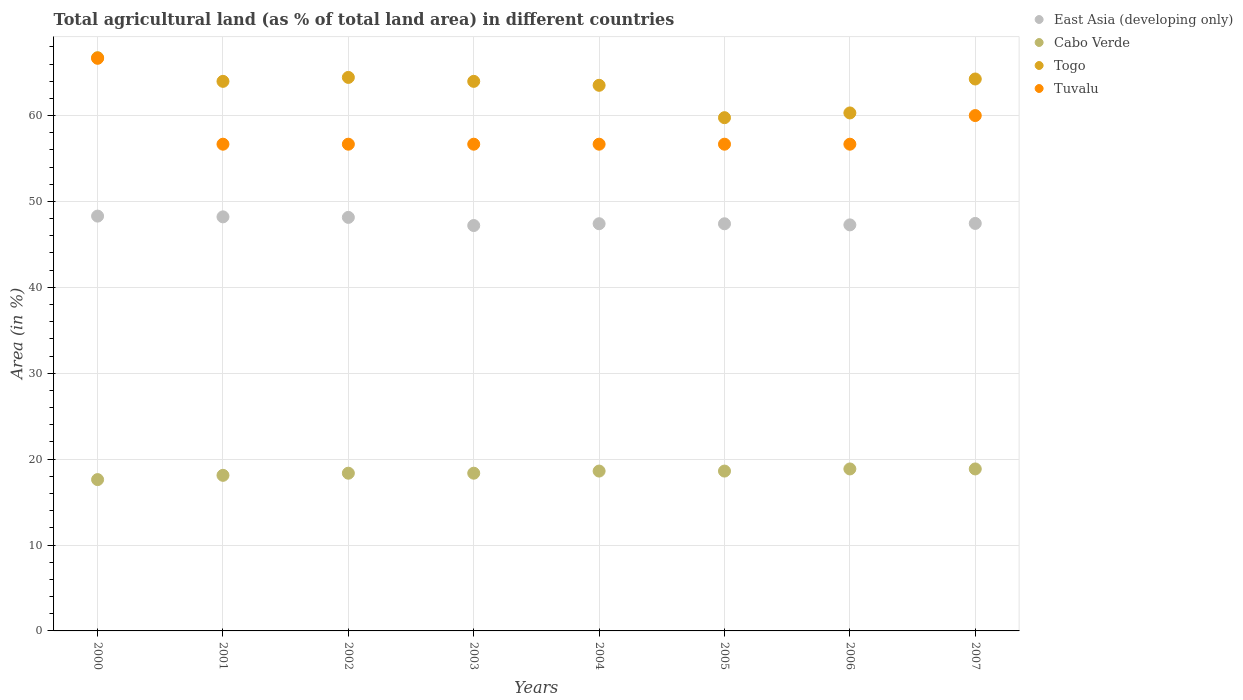Is the number of dotlines equal to the number of legend labels?
Provide a succinct answer. Yes. What is the percentage of agricultural land in Tuvalu in 2003?
Make the answer very short. 56.67. Across all years, what is the maximum percentage of agricultural land in Togo?
Make the answer very short. 66.74. Across all years, what is the minimum percentage of agricultural land in Cabo Verde?
Make the answer very short. 17.62. In which year was the percentage of agricultural land in Cabo Verde maximum?
Your answer should be very brief. 2006. In which year was the percentage of agricultural land in Togo minimum?
Give a very brief answer. 2005. What is the total percentage of agricultural land in East Asia (developing only) in the graph?
Offer a very short reply. 381.37. What is the difference between the percentage of agricultural land in East Asia (developing only) in 2006 and that in 2007?
Keep it short and to the point. -0.17. What is the difference between the percentage of agricultural land in East Asia (developing only) in 2004 and the percentage of agricultural land in Cabo Verde in 2002?
Make the answer very short. 29.05. What is the average percentage of agricultural land in Tuvalu per year?
Ensure brevity in your answer.  58.33. In the year 2000, what is the difference between the percentage of agricultural land in Togo and percentage of agricultural land in East Asia (developing only)?
Give a very brief answer. 18.45. In how many years, is the percentage of agricultural land in Togo greater than 52 %?
Provide a short and direct response. 8. What is the ratio of the percentage of agricultural land in Cabo Verde in 2002 to that in 2007?
Provide a succinct answer. 0.97. Is the percentage of agricultural land in Tuvalu in 2002 less than that in 2005?
Give a very brief answer. No. What is the difference between the highest and the second highest percentage of agricultural land in East Asia (developing only)?
Offer a terse response. 0.09. What is the difference between the highest and the lowest percentage of agricultural land in Cabo Verde?
Ensure brevity in your answer.  1.24. In how many years, is the percentage of agricultural land in Tuvalu greater than the average percentage of agricultural land in Tuvalu taken over all years?
Keep it short and to the point. 2. Is the sum of the percentage of agricultural land in Cabo Verde in 2006 and 2007 greater than the maximum percentage of agricultural land in East Asia (developing only) across all years?
Your answer should be compact. No. Does the percentage of agricultural land in Cabo Verde monotonically increase over the years?
Your answer should be very brief. No. How many dotlines are there?
Give a very brief answer. 4. How many years are there in the graph?
Offer a very short reply. 8. What is the difference between two consecutive major ticks on the Y-axis?
Your response must be concise. 10. Does the graph contain grids?
Make the answer very short. Yes. Where does the legend appear in the graph?
Make the answer very short. Top right. How are the legend labels stacked?
Provide a short and direct response. Vertical. What is the title of the graph?
Offer a terse response. Total agricultural land (as % of total land area) in different countries. Does "Ghana" appear as one of the legend labels in the graph?
Your answer should be compact. No. What is the label or title of the Y-axis?
Provide a short and direct response. Area (in %). What is the Area (in %) in East Asia (developing only) in 2000?
Offer a very short reply. 48.3. What is the Area (in %) in Cabo Verde in 2000?
Make the answer very short. 17.62. What is the Area (in %) of Togo in 2000?
Make the answer very short. 66.74. What is the Area (in %) in Tuvalu in 2000?
Offer a very short reply. 66.67. What is the Area (in %) in East Asia (developing only) in 2001?
Keep it short and to the point. 48.21. What is the Area (in %) in Cabo Verde in 2001?
Offer a very short reply. 18.11. What is the Area (in %) in Togo in 2001?
Keep it short and to the point. 63.98. What is the Area (in %) in Tuvalu in 2001?
Offer a very short reply. 56.67. What is the Area (in %) of East Asia (developing only) in 2002?
Offer a terse response. 48.15. What is the Area (in %) in Cabo Verde in 2002?
Ensure brevity in your answer.  18.36. What is the Area (in %) in Togo in 2002?
Give a very brief answer. 64.44. What is the Area (in %) in Tuvalu in 2002?
Offer a terse response. 56.67. What is the Area (in %) in East Asia (developing only) in 2003?
Your answer should be compact. 47.2. What is the Area (in %) of Cabo Verde in 2003?
Keep it short and to the point. 18.36. What is the Area (in %) in Togo in 2003?
Your answer should be compact. 63.98. What is the Area (in %) in Tuvalu in 2003?
Give a very brief answer. 56.67. What is the Area (in %) in East Asia (developing only) in 2004?
Keep it short and to the point. 47.41. What is the Area (in %) of Cabo Verde in 2004?
Provide a short and direct response. 18.61. What is the Area (in %) in Togo in 2004?
Provide a short and direct response. 63.52. What is the Area (in %) in Tuvalu in 2004?
Keep it short and to the point. 56.67. What is the Area (in %) in East Asia (developing only) in 2005?
Give a very brief answer. 47.4. What is the Area (in %) of Cabo Verde in 2005?
Offer a very short reply. 18.61. What is the Area (in %) of Togo in 2005?
Offer a terse response. 59.75. What is the Area (in %) in Tuvalu in 2005?
Your response must be concise. 56.67. What is the Area (in %) in East Asia (developing only) in 2006?
Make the answer very short. 47.27. What is the Area (in %) in Cabo Verde in 2006?
Provide a succinct answer. 18.86. What is the Area (in %) of Togo in 2006?
Make the answer very short. 60.31. What is the Area (in %) in Tuvalu in 2006?
Make the answer very short. 56.67. What is the Area (in %) in East Asia (developing only) in 2007?
Ensure brevity in your answer.  47.44. What is the Area (in %) in Cabo Verde in 2007?
Offer a very short reply. 18.86. What is the Area (in %) in Togo in 2007?
Provide a succinct answer. 64.26. Across all years, what is the maximum Area (in %) of East Asia (developing only)?
Your response must be concise. 48.3. Across all years, what is the maximum Area (in %) in Cabo Verde?
Make the answer very short. 18.86. Across all years, what is the maximum Area (in %) in Togo?
Provide a short and direct response. 66.74. Across all years, what is the maximum Area (in %) of Tuvalu?
Provide a succinct answer. 66.67. Across all years, what is the minimum Area (in %) in East Asia (developing only)?
Make the answer very short. 47.2. Across all years, what is the minimum Area (in %) in Cabo Verde?
Give a very brief answer. 17.62. Across all years, what is the minimum Area (in %) in Togo?
Your response must be concise. 59.75. Across all years, what is the minimum Area (in %) in Tuvalu?
Offer a very short reply. 56.67. What is the total Area (in %) of East Asia (developing only) in the graph?
Ensure brevity in your answer.  381.37. What is the total Area (in %) in Cabo Verde in the graph?
Your answer should be compact. 147.39. What is the total Area (in %) in Togo in the graph?
Ensure brevity in your answer.  506.99. What is the total Area (in %) of Tuvalu in the graph?
Keep it short and to the point. 466.67. What is the difference between the Area (in %) of East Asia (developing only) in 2000 and that in 2001?
Give a very brief answer. 0.09. What is the difference between the Area (in %) in Cabo Verde in 2000 and that in 2001?
Your response must be concise. -0.5. What is the difference between the Area (in %) of Togo in 2000 and that in 2001?
Keep it short and to the point. 2.76. What is the difference between the Area (in %) of East Asia (developing only) in 2000 and that in 2002?
Your answer should be very brief. 0.15. What is the difference between the Area (in %) of Cabo Verde in 2000 and that in 2002?
Your answer should be compact. -0.74. What is the difference between the Area (in %) of Togo in 2000 and that in 2002?
Provide a short and direct response. 2.3. What is the difference between the Area (in %) of East Asia (developing only) in 2000 and that in 2003?
Your answer should be very brief. 1.1. What is the difference between the Area (in %) of Cabo Verde in 2000 and that in 2003?
Keep it short and to the point. -0.74. What is the difference between the Area (in %) of Togo in 2000 and that in 2003?
Offer a very short reply. 2.76. What is the difference between the Area (in %) in East Asia (developing only) in 2000 and that in 2004?
Provide a succinct answer. 0.89. What is the difference between the Area (in %) of Cabo Verde in 2000 and that in 2004?
Provide a succinct answer. -0.99. What is the difference between the Area (in %) of Togo in 2000 and that in 2004?
Keep it short and to the point. 3.22. What is the difference between the Area (in %) in Tuvalu in 2000 and that in 2004?
Give a very brief answer. 10. What is the difference between the Area (in %) of East Asia (developing only) in 2000 and that in 2005?
Provide a succinct answer. 0.89. What is the difference between the Area (in %) in Cabo Verde in 2000 and that in 2005?
Your answer should be very brief. -0.99. What is the difference between the Area (in %) of Togo in 2000 and that in 2005?
Your answer should be very brief. 6.99. What is the difference between the Area (in %) in East Asia (developing only) in 2000 and that in 2006?
Provide a short and direct response. 1.02. What is the difference between the Area (in %) in Cabo Verde in 2000 and that in 2006?
Provide a succinct answer. -1.24. What is the difference between the Area (in %) of Togo in 2000 and that in 2006?
Ensure brevity in your answer.  6.43. What is the difference between the Area (in %) in Tuvalu in 2000 and that in 2006?
Give a very brief answer. 10. What is the difference between the Area (in %) of East Asia (developing only) in 2000 and that in 2007?
Give a very brief answer. 0.85. What is the difference between the Area (in %) of Cabo Verde in 2000 and that in 2007?
Your answer should be compact. -1.24. What is the difference between the Area (in %) in Togo in 2000 and that in 2007?
Your answer should be very brief. 2.48. What is the difference between the Area (in %) of Tuvalu in 2000 and that in 2007?
Your answer should be very brief. 6.67. What is the difference between the Area (in %) in East Asia (developing only) in 2001 and that in 2002?
Provide a succinct answer. 0.06. What is the difference between the Area (in %) of Cabo Verde in 2001 and that in 2002?
Your answer should be compact. -0.25. What is the difference between the Area (in %) of Togo in 2001 and that in 2002?
Make the answer very short. -0.46. What is the difference between the Area (in %) of Cabo Verde in 2001 and that in 2003?
Offer a very short reply. -0.25. What is the difference between the Area (in %) in East Asia (developing only) in 2001 and that in 2004?
Your answer should be compact. 0.8. What is the difference between the Area (in %) of Cabo Verde in 2001 and that in 2004?
Provide a succinct answer. -0.5. What is the difference between the Area (in %) in Togo in 2001 and that in 2004?
Provide a short and direct response. 0.46. What is the difference between the Area (in %) in East Asia (developing only) in 2001 and that in 2005?
Provide a short and direct response. 0.8. What is the difference between the Area (in %) in Cabo Verde in 2001 and that in 2005?
Ensure brevity in your answer.  -0.5. What is the difference between the Area (in %) of Togo in 2001 and that in 2005?
Keep it short and to the point. 4.23. What is the difference between the Area (in %) of Tuvalu in 2001 and that in 2005?
Give a very brief answer. 0. What is the difference between the Area (in %) of East Asia (developing only) in 2001 and that in 2006?
Provide a succinct answer. 0.93. What is the difference between the Area (in %) of Cabo Verde in 2001 and that in 2006?
Keep it short and to the point. -0.74. What is the difference between the Area (in %) of Togo in 2001 and that in 2006?
Your answer should be very brief. 3.68. What is the difference between the Area (in %) in Tuvalu in 2001 and that in 2006?
Your response must be concise. 0. What is the difference between the Area (in %) of East Asia (developing only) in 2001 and that in 2007?
Your response must be concise. 0.76. What is the difference between the Area (in %) of Cabo Verde in 2001 and that in 2007?
Ensure brevity in your answer.  -0.74. What is the difference between the Area (in %) of Togo in 2001 and that in 2007?
Provide a short and direct response. -0.28. What is the difference between the Area (in %) in East Asia (developing only) in 2002 and that in 2003?
Ensure brevity in your answer.  0.95. What is the difference between the Area (in %) of Cabo Verde in 2002 and that in 2003?
Your response must be concise. 0. What is the difference between the Area (in %) in Togo in 2002 and that in 2003?
Keep it short and to the point. 0.46. What is the difference between the Area (in %) of East Asia (developing only) in 2002 and that in 2004?
Provide a succinct answer. 0.74. What is the difference between the Area (in %) of Cabo Verde in 2002 and that in 2004?
Offer a very short reply. -0.25. What is the difference between the Area (in %) of Togo in 2002 and that in 2004?
Provide a short and direct response. 0.92. What is the difference between the Area (in %) of East Asia (developing only) in 2002 and that in 2005?
Offer a very short reply. 0.74. What is the difference between the Area (in %) in Cabo Verde in 2002 and that in 2005?
Offer a terse response. -0.25. What is the difference between the Area (in %) of Togo in 2002 and that in 2005?
Make the answer very short. 4.69. What is the difference between the Area (in %) of Tuvalu in 2002 and that in 2005?
Provide a succinct answer. 0. What is the difference between the Area (in %) of East Asia (developing only) in 2002 and that in 2006?
Your response must be concise. 0.87. What is the difference between the Area (in %) in Cabo Verde in 2002 and that in 2006?
Your response must be concise. -0.5. What is the difference between the Area (in %) of Togo in 2002 and that in 2006?
Keep it short and to the point. 4.14. What is the difference between the Area (in %) in East Asia (developing only) in 2002 and that in 2007?
Keep it short and to the point. 0.7. What is the difference between the Area (in %) of Cabo Verde in 2002 and that in 2007?
Your response must be concise. -0.5. What is the difference between the Area (in %) of Togo in 2002 and that in 2007?
Your answer should be very brief. 0.18. What is the difference between the Area (in %) of Tuvalu in 2002 and that in 2007?
Give a very brief answer. -3.33. What is the difference between the Area (in %) in East Asia (developing only) in 2003 and that in 2004?
Your response must be concise. -0.21. What is the difference between the Area (in %) in Cabo Verde in 2003 and that in 2004?
Your answer should be very brief. -0.25. What is the difference between the Area (in %) in Togo in 2003 and that in 2004?
Your response must be concise. 0.46. What is the difference between the Area (in %) in East Asia (developing only) in 2003 and that in 2005?
Your response must be concise. -0.21. What is the difference between the Area (in %) in Cabo Verde in 2003 and that in 2005?
Your answer should be very brief. -0.25. What is the difference between the Area (in %) of Togo in 2003 and that in 2005?
Your answer should be very brief. 4.23. What is the difference between the Area (in %) of Tuvalu in 2003 and that in 2005?
Give a very brief answer. 0. What is the difference between the Area (in %) of East Asia (developing only) in 2003 and that in 2006?
Your response must be concise. -0.08. What is the difference between the Area (in %) of Cabo Verde in 2003 and that in 2006?
Your response must be concise. -0.5. What is the difference between the Area (in %) of Togo in 2003 and that in 2006?
Your response must be concise. 3.68. What is the difference between the Area (in %) in Tuvalu in 2003 and that in 2006?
Your response must be concise. 0. What is the difference between the Area (in %) of East Asia (developing only) in 2003 and that in 2007?
Offer a terse response. -0.25. What is the difference between the Area (in %) of Cabo Verde in 2003 and that in 2007?
Your answer should be compact. -0.5. What is the difference between the Area (in %) in Togo in 2003 and that in 2007?
Offer a very short reply. -0.28. What is the difference between the Area (in %) of East Asia (developing only) in 2004 and that in 2005?
Your answer should be very brief. 0.01. What is the difference between the Area (in %) of Cabo Verde in 2004 and that in 2005?
Offer a terse response. 0. What is the difference between the Area (in %) of Togo in 2004 and that in 2005?
Offer a terse response. 3.77. What is the difference between the Area (in %) of East Asia (developing only) in 2004 and that in 2006?
Your response must be concise. 0.14. What is the difference between the Area (in %) in Cabo Verde in 2004 and that in 2006?
Keep it short and to the point. -0.25. What is the difference between the Area (in %) of Togo in 2004 and that in 2006?
Keep it short and to the point. 3.22. What is the difference between the Area (in %) of Tuvalu in 2004 and that in 2006?
Offer a terse response. 0. What is the difference between the Area (in %) of East Asia (developing only) in 2004 and that in 2007?
Your answer should be very brief. -0.03. What is the difference between the Area (in %) of Cabo Verde in 2004 and that in 2007?
Provide a short and direct response. -0.25. What is the difference between the Area (in %) in Togo in 2004 and that in 2007?
Give a very brief answer. -0.74. What is the difference between the Area (in %) of East Asia (developing only) in 2005 and that in 2006?
Make the answer very short. 0.13. What is the difference between the Area (in %) in Cabo Verde in 2005 and that in 2006?
Keep it short and to the point. -0.25. What is the difference between the Area (in %) in Togo in 2005 and that in 2006?
Provide a short and direct response. -0.55. What is the difference between the Area (in %) in Tuvalu in 2005 and that in 2006?
Provide a succinct answer. 0. What is the difference between the Area (in %) in East Asia (developing only) in 2005 and that in 2007?
Make the answer very short. -0.04. What is the difference between the Area (in %) of Cabo Verde in 2005 and that in 2007?
Your answer should be very brief. -0.25. What is the difference between the Area (in %) in Togo in 2005 and that in 2007?
Your response must be concise. -4.5. What is the difference between the Area (in %) of East Asia (developing only) in 2006 and that in 2007?
Your answer should be compact. -0.17. What is the difference between the Area (in %) in Togo in 2006 and that in 2007?
Offer a terse response. -3.95. What is the difference between the Area (in %) of East Asia (developing only) in 2000 and the Area (in %) of Cabo Verde in 2001?
Your answer should be compact. 30.18. What is the difference between the Area (in %) of East Asia (developing only) in 2000 and the Area (in %) of Togo in 2001?
Provide a succinct answer. -15.69. What is the difference between the Area (in %) of East Asia (developing only) in 2000 and the Area (in %) of Tuvalu in 2001?
Your response must be concise. -8.37. What is the difference between the Area (in %) in Cabo Verde in 2000 and the Area (in %) in Togo in 2001?
Offer a very short reply. -46.36. What is the difference between the Area (in %) of Cabo Verde in 2000 and the Area (in %) of Tuvalu in 2001?
Your answer should be very brief. -39.05. What is the difference between the Area (in %) in Togo in 2000 and the Area (in %) in Tuvalu in 2001?
Offer a terse response. 10.07. What is the difference between the Area (in %) in East Asia (developing only) in 2000 and the Area (in %) in Cabo Verde in 2002?
Make the answer very short. 29.93. What is the difference between the Area (in %) in East Asia (developing only) in 2000 and the Area (in %) in Togo in 2002?
Keep it short and to the point. -16.15. What is the difference between the Area (in %) in East Asia (developing only) in 2000 and the Area (in %) in Tuvalu in 2002?
Provide a succinct answer. -8.37. What is the difference between the Area (in %) in Cabo Verde in 2000 and the Area (in %) in Togo in 2002?
Make the answer very short. -46.82. What is the difference between the Area (in %) of Cabo Verde in 2000 and the Area (in %) of Tuvalu in 2002?
Your answer should be very brief. -39.05. What is the difference between the Area (in %) in Togo in 2000 and the Area (in %) in Tuvalu in 2002?
Offer a very short reply. 10.07. What is the difference between the Area (in %) in East Asia (developing only) in 2000 and the Area (in %) in Cabo Verde in 2003?
Provide a succinct answer. 29.93. What is the difference between the Area (in %) of East Asia (developing only) in 2000 and the Area (in %) of Togo in 2003?
Offer a very short reply. -15.69. What is the difference between the Area (in %) of East Asia (developing only) in 2000 and the Area (in %) of Tuvalu in 2003?
Offer a terse response. -8.37. What is the difference between the Area (in %) in Cabo Verde in 2000 and the Area (in %) in Togo in 2003?
Your response must be concise. -46.36. What is the difference between the Area (in %) of Cabo Verde in 2000 and the Area (in %) of Tuvalu in 2003?
Offer a very short reply. -39.05. What is the difference between the Area (in %) of Togo in 2000 and the Area (in %) of Tuvalu in 2003?
Make the answer very short. 10.07. What is the difference between the Area (in %) in East Asia (developing only) in 2000 and the Area (in %) in Cabo Verde in 2004?
Offer a terse response. 29.68. What is the difference between the Area (in %) in East Asia (developing only) in 2000 and the Area (in %) in Togo in 2004?
Your answer should be very brief. -15.23. What is the difference between the Area (in %) in East Asia (developing only) in 2000 and the Area (in %) in Tuvalu in 2004?
Provide a short and direct response. -8.37. What is the difference between the Area (in %) in Cabo Verde in 2000 and the Area (in %) in Togo in 2004?
Provide a short and direct response. -45.9. What is the difference between the Area (in %) of Cabo Verde in 2000 and the Area (in %) of Tuvalu in 2004?
Keep it short and to the point. -39.05. What is the difference between the Area (in %) in Togo in 2000 and the Area (in %) in Tuvalu in 2004?
Keep it short and to the point. 10.07. What is the difference between the Area (in %) in East Asia (developing only) in 2000 and the Area (in %) in Cabo Verde in 2005?
Offer a very short reply. 29.68. What is the difference between the Area (in %) of East Asia (developing only) in 2000 and the Area (in %) of Togo in 2005?
Ensure brevity in your answer.  -11.46. What is the difference between the Area (in %) in East Asia (developing only) in 2000 and the Area (in %) in Tuvalu in 2005?
Provide a short and direct response. -8.37. What is the difference between the Area (in %) of Cabo Verde in 2000 and the Area (in %) of Togo in 2005?
Make the answer very short. -42.14. What is the difference between the Area (in %) of Cabo Verde in 2000 and the Area (in %) of Tuvalu in 2005?
Your answer should be compact. -39.05. What is the difference between the Area (in %) of Togo in 2000 and the Area (in %) of Tuvalu in 2005?
Offer a terse response. 10.07. What is the difference between the Area (in %) of East Asia (developing only) in 2000 and the Area (in %) of Cabo Verde in 2006?
Offer a very short reply. 29.44. What is the difference between the Area (in %) of East Asia (developing only) in 2000 and the Area (in %) of Togo in 2006?
Offer a terse response. -12.01. What is the difference between the Area (in %) in East Asia (developing only) in 2000 and the Area (in %) in Tuvalu in 2006?
Make the answer very short. -8.37. What is the difference between the Area (in %) of Cabo Verde in 2000 and the Area (in %) of Togo in 2006?
Provide a short and direct response. -42.69. What is the difference between the Area (in %) of Cabo Verde in 2000 and the Area (in %) of Tuvalu in 2006?
Your answer should be very brief. -39.05. What is the difference between the Area (in %) of Togo in 2000 and the Area (in %) of Tuvalu in 2006?
Ensure brevity in your answer.  10.07. What is the difference between the Area (in %) of East Asia (developing only) in 2000 and the Area (in %) of Cabo Verde in 2007?
Offer a very short reply. 29.44. What is the difference between the Area (in %) in East Asia (developing only) in 2000 and the Area (in %) in Togo in 2007?
Keep it short and to the point. -15.96. What is the difference between the Area (in %) in East Asia (developing only) in 2000 and the Area (in %) in Tuvalu in 2007?
Your response must be concise. -11.7. What is the difference between the Area (in %) of Cabo Verde in 2000 and the Area (in %) of Togo in 2007?
Ensure brevity in your answer.  -46.64. What is the difference between the Area (in %) in Cabo Verde in 2000 and the Area (in %) in Tuvalu in 2007?
Your response must be concise. -42.38. What is the difference between the Area (in %) in Togo in 2000 and the Area (in %) in Tuvalu in 2007?
Provide a succinct answer. 6.74. What is the difference between the Area (in %) of East Asia (developing only) in 2001 and the Area (in %) of Cabo Verde in 2002?
Your answer should be compact. 29.84. What is the difference between the Area (in %) in East Asia (developing only) in 2001 and the Area (in %) in Togo in 2002?
Your answer should be very brief. -16.24. What is the difference between the Area (in %) in East Asia (developing only) in 2001 and the Area (in %) in Tuvalu in 2002?
Make the answer very short. -8.46. What is the difference between the Area (in %) in Cabo Verde in 2001 and the Area (in %) in Togo in 2002?
Keep it short and to the point. -46.33. What is the difference between the Area (in %) of Cabo Verde in 2001 and the Area (in %) of Tuvalu in 2002?
Offer a very short reply. -38.55. What is the difference between the Area (in %) of Togo in 2001 and the Area (in %) of Tuvalu in 2002?
Provide a succinct answer. 7.32. What is the difference between the Area (in %) of East Asia (developing only) in 2001 and the Area (in %) of Cabo Verde in 2003?
Keep it short and to the point. 29.84. What is the difference between the Area (in %) of East Asia (developing only) in 2001 and the Area (in %) of Togo in 2003?
Your answer should be compact. -15.78. What is the difference between the Area (in %) of East Asia (developing only) in 2001 and the Area (in %) of Tuvalu in 2003?
Make the answer very short. -8.46. What is the difference between the Area (in %) of Cabo Verde in 2001 and the Area (in %) of Togo in 2003?
Your response must be concise. -45.87. What is the difference between the Area (in %) of Cabo Verde in 2001 and the Area (in %) of Tuvalu in 2003?
Provide a succinct answer. -38.55. What is the difference between the Area (in %) in Togo in 2001 and the Area (in %) in Tuvalu in 2003?
Provide a succinct answer. 7.32. What is the difference between the Area (in %) of East Asia (developing only) in 2001 and the Area (in %) of Cabo Verde in 2004?
Your response must be concise. 29.6. What is the difference between the Area (in %) in East Asia (developing only) in 2001 and the Area (in %) in Togo in 2004?
Offer a terse response. -15.32. What is the difference between the Area (in %) of East Asia (developing only) in 2001 and the Area (in %) of Tuvalu in 2004?
Your answer should be compact. -8.46. What is the difference between the Area (in %) in Cabo Verde in 2001 and the Area (in %) in Togo in 2004?
Keep it short and to the point. -45.41. What is the difference between the Area (in %) in Cabo Verde in 2001 and the Area (in %) in Tuvalu in 2004?
Your answer should be compact. -38.55. What is the difference between the Area (in %) of Togo in 2001 and the Area (in %) of Tuvalu in 2004?
Your response must be concise. 7.32. What is the difference between the Area (in %) of East Asia (developing only) in 2001 and the Area (in %) of Cabo Verde in 2005?
Your answer should be compact. 29.6. What is the difference between the Area (in %) of East Asia (developing only) in 2001 and the Area (in %) of Togo in 2005?
Offer a very short reply. -11.55. What is the difference between the Area (in %) of East Asia (developing only) in 2001 and the Area (in %) of Tuvalu in 2005?
Make the answer very short. -8.46. What is the difference between the Area (in %) of Cabo Verde in 2001 and the Area (in %) of Togo in 2005?
Provide a short and direct response. -41.64. What is the difference between the Area (in %) in Cabo Verde in 2001 and the Area (in %) in Tuvalu in 2005?
Keep it short and to the point. -38.55. What is the difference between the Area (in %) in Togo in 2001 and the Area (in %) in Tuvalu in 2005?
Give a very brief answer. 7.32. What is the difference between the Area (in %) of East Asia (developing only) in 2001 and the Area (in %) of Cabo Verde in 2006?
Give a very brief answer. 29.35. What is the difference between the Area (in %) in East Asia (developing only) in 2001 and the Area (in %) in Togo in 2006?
Your answer should be very brief. -12.1. What is the difference between the Area (in %) of East Asia (developing only) in 2001 and the Area (in %) of Tuvalu in 2006?
Offer a terse response. -8.46. What is the difference between the Area (in %) in Cabo Verde in 2001 and the Area (in %) in Togo in 2006?
Make the answer very short. -42.19. What is the difference between the Area (in %) of Cabo Verde in 2001 and the Area (in %) of Tuvalu in 2006?
Your answer should be very brief. -38.55. What is the difference between the Area (in %) of Togo in 2001 and the Area (in %) of Tuvalu in 2006?
Provide a short and direct response. 7.32. What is the difference between the Area (in %) in East Asia (developing only) in 2001 and the Area (in %) in Cabo Verde in 2007?
Ensure brevity in your answer.  29.35. What is the difference between the Area (in %) in East Asia (developing only) in 2001 and the Area (in %) in Togo in 2007?
Keep it short and to the point. -16.05. What is the difference between the Area (in %) in East Asia (developing only) in 2001 and the Area (in %) in Tuvalu in 2007?
Offer a terse response. -11.79. What is the difference between the Area (in %) of Cabo Verde in 2001 and the Area (in %) of Togo in 2007?
Ensure brevity in your answer.  -46.14. What is the difference between the Area (in %) in Cabo Verde in 2001 and the Area (in %) in Tuvalu in 2007?
Keep it short and to the point. -41.89. What is the difference between the Area (in %) of Togo in 2001 and the Area (in %) of Tuvalu in 2007?
Make the answer very short. 3.98. What is the difference between the Area (in %) in East Asia (developing only) in 2002 and the Area (in %) in Cabo Verde in 2003?
Make the answer very short. 29.78. What is the difference between the Area (in %) in East Asia (developing only) in 2002 and the Area (in %) in Togo in 2003?
Provide a short and direct response. -15.84. What is the difference between the Area (in %) in East Asia (developing only) in 2002 and the Area (in %) in Tuvalu in 2003?
Your response must be concise. -8.52. What is the difference between the Area (in %) in Cabo Verde in 2002 and the Area (in %) in Togo in 2003?
Your answer should be very brief. -45.62. What is the difference between the Area (in %) in Cabo Verde in 2002 and the Area (in %) in Tuvalu in 2003?
Offer a terse response. -38.3. What is the difference between the Area (in %) of Togo in 2002 and the Area (in %) of Tuvalu in 2003?
Keep it short and to the point. 7.78. What is the difference between the Area (in %) of East Asia (developing only) in 2002 and the Area (in %) of Cabo Verde in 2004?
Give a very brief answer. 29.54. What is the difference between the Area (in %) in East Asia (developing only) in 2002 and the Area (in %) in Togo in 2004?
Give a very brief answer. -15.38. What is the difference between the Area (in %) of East Asia (developing only) in 2002 and the Area (in %) of Tuvalu in 2004?
Your answer should be very brief. -8.52. What is the difference between the Area (in %) of Cabo Verde in 2002 and the Area (in %) of Togo in 2004?
Make the answer very short. -45.16. What is the difference between the Area (in %) in Cabo Verde in 2002 and the Area (in %) in Tuvalu in 2004?
Make the answer very short. -38.3. What is the difference between the Area (in %) in Togo in 2002 and the Area (in %) in Tuvalu in 2004?
Your answer should be compact. 7.78. What is the difference between the Area (in %) of East Asia (developing only) in 2002 and the Area (in %) of Cabo Verde in 2005?
Offer a terse response. 29.54. What is the difference between the Area (in %) of East Asia (developing only) in 2002 and the Area (in %) of Togo in 2005?
Your answer should be compact. -11.61. What is the difference between the Area (in %) in East Asia (developing only) in 2002 and the Area (in %) in Tuvalu in 2005?
Offer a terse response. -8.52. What is the difference between the Area (in %) of Cabo Verde in 2002 and the Area (in %) of Togo in 2005?
Offer a terse response. -41.39. What is the difference between the Area (in %) of Cabo Verde in 2002 and the Area (in %) of Tuvalu in 2005?
Provide a succinct answer. -38.3. What is the difference between the Area (in %) in Togo in 2002 and the Area (in %) in Tuvalu in 2005?
Ensure brevity in your answer.  7.78. What is the difference between the Area (in %) in East Asia (developing only) in 2002 and the Area (in %) in Cabo Verde in 2006?
Your response must be concise. 29.29. What is the difference between the Area (in %) in East Asia (developing only) in 2002 and the Area (in %) in Togo in 2006?
Your response must be concise. -12.16. What is the difference between the Area (in %) of East Asia (developing only) in 2002 and the Area (in %) of Tuvalu in 2006?
Make the answer very short. -8.52. What is the difference between the Area (in %) of Cabo Verde in 2002 and the Area (in %) of Togo in 2006?
Your answer should be very brief. -41.94. What is the difference between the Area (in %) of Cabo Verde in 2002 and the Area (in %) of Tuvalu in 2006?
Provide a succinct answer. -38.3. What is the difference between the Area (in %) in Togo in 2002 and the Area (in %) in Tuvalu in 2006?
Provide a succinct answer. 7.78. What is the difference between the Area (in %) in East Asia (developing only) in 2002 and the Area (in %) in Cabo Verde in 2007?
Provide a short and direct response. 29.29. What is the difference between the Area (in %) of East Asia (developing only) in 2002 and the Area (in %) of Togo in 2007?
Offer a very short reply. -16.11. What is the difference between the Area (in %) of East Asia (developing only) in 2002 and the Area (in %) of Tuvalu in 2007?
Your answer should be very brief. -11.85. What is the difference between the Area (in %) of Cabo Verde in 2002 and the Area (in %) of Togo in 2007?
Offer a terse response. -45.9. What is the difference between the Area (in %) in Cabo Verde in 2002 and the Area (in %) in Tuvalu in 2007?
Keep it short and to the point. -41.64. What is the difference between the Area (in %) in Togo in 2002 and the Area (in %) in Tuvalu in 2007?
Your answer should be very brief. 4.44. What is the difference between the Area (in %) of East Asia (developing only) in 2003 and the Area (in %) of Cabo Verde in 2004?
Your response must be concise. 28.59. What is the difference between the Area (in %) in East Asia (developing only) in 2003 and the Area (in %) in Togo in 2004?
Keep it short and to the point. -16.33. What is the difference between the Area (in %) in East Asia (developing only) in 2003 and the Area (in %) in Tuvalu in 2004?
Your answer should be very brief. -9.47. What is the difference between the Area (in %) in Cabo Verde in 2003 and the Area (in %) in Togo in 2004?
Keep it short and to the point. -45.16. What is the difference between the Area (in %) of Cabo Verde in 2003 and the Area (in %) of Tuvalu in 2004?
Offer a very short reply. -38.3. What is the difference between the Area (in %) of Togo in 2003 and the Area (in %) of Tuvalu in 2004?
Offer a very short reply. 7.32. What is the difference between the Area (in %) in East Asia (developing only) in 2003 and the Area (in %) in Cabo Verde in 2005?
Ensure brevity in your answer.  28.59. What is the difference between the Area (in %) of East Asia (developing only) in 2003 and the Area (in %) of Togo in 2005?
Provide a succinct answer. -12.56. What is the difference between the Area (in %) in East Asia (developing only) in 2003 and the Area (in %) in Tuvalu in 2005?
Make the answer very short. -9.47. What is the difference between the Area (in %) of Cabo Verde in 2003 and the Area (in %) of Togo in 2005?
Provide a short and direct response. -41.39. What is the difference between the Area (in %) in Cabo Verde in 2003 and the Area (in %) in Tuvalu in 2005?
Ensure brevity in your answer.  -38.3. What is the difference between the Area (in %) in Togo in 2003 and the Area (in %) in Tuvalu in 2005?
Provide a succinct answer. 7.32. What is the difference between the Area (in %) in East Asia (developing only) in 2003 and the Area (in %) in Cabo Verde in 2006?
Offer a very short reply. 28.34. What is the difference between the Area (in %) in East Asia (developing only) in 2003 and the Area (in %) in Togo in 2006?
Give a very brief answer. -13.11. What is the difference between the Area (in %) in East Asia (developing only) in 2003 and the Area (in %) in Tuvalu in 2006?
Make the answer very short. -9.47. What is the difference between the Area (in %) in Cabo Verde in 2003 and the Area (in %) in Togo in 2006?
Offer a terse response. -41.94. What is the difference between the Area (in %) of Cabo Verde in 2003 and the Area (in %) of Tuvalu in 2006?
Keep it short and to the point. -38.3. What is the difference between the Area (in %) in Togo in 2003 and the Area (in %) in Tuvalu in 2006?
Your response must be concise. 7.32. What is the difference between the Area (in %) in East Asia (developing only) in 2003 and the Area (in %) in Cabo Verde in 2007?
Offer a very short reply. 28.34. What is the difference between the Area (in %) in East Asia (developing only) in 2003 and the Area (in %) in Togo in 2007?
Your answer should be very brief. -17.06. What is the difference between the Area (in %) of East Asia (developing only) in 2003 and the Area (in %) of Tuvalu in 2007?
Provide a succinct answer. -12.8. What is the difference between the Area (in %) in Cabo Verde in 2003 and the Area (in %) in Togo in 2007?
Make the answer very short. -45.9. What is the difference between the Area (in %) in Cabo Verde in 2003 and the Area (in %) in Tuvalu in 2007?
Your answer should be compact. -41.64. What is the difference between the Area (in %) of Togo in 2003 and the Area (in %) of Tuvalu in 2007?
Ensure brevity in your answer.  3.98. What is the difference between the Area (in %) of East Asia (developing only) in 2004 and the Area (in %) of Cabo Verde in 2005?
Offer a terse response. 28.8. What is the difference between the Area (in %) in East Asia (developing only) in 2004 and the Area (in %) in Togo in 2005?
Keep it short and to the point. -12.35. What is the difference between the Area (in %) in East Asia (developing only) in 2004 and the Area (in %) in Tuvalu in 2005?
Your answer should be compact. -9.26. What is the difference between the Area (in %) of Cabo Verde in 2004 and the Area (in %) of Togo in 2005?
Provide a short and direct response. -41.14. What is the difference between the Area (in %) in Cabo Verde in 2004 and the Area (in %) in Tuvalu in 2005?
Your answer should be compact. -38.06. What is the difference between the Area (in %) in Togo in 2004 and the Area (in %) in Tuvalu in 2005?
Keep it short and to the point. 6.86. What is the difference between the Area (in %) in East Asia (developing only) in 2004 and the Area (in %) in Cabo Verde in 2006?
Offer a very short reply. 28.55. What is the difference between the Area (in %) in East Asia (developing only) in 2004 and the Area (in %) in Togo in 2006?
Ensure brevity in your answer.  -12.9. What is the difference between the Area (in %) in East Asia (developing only) in 2004 and the Area (in %) in Tuvalu in 2006?
Make the answer very short. -9.26. What is the difference between the Area (in %) of Cabo Verde in 2004 and the Area (in %) of Togo in 2006?
Offer a terse response. -41.69. What is the difference between the Area (in %) in Cabo Verde in 2004 and the Area (in %) in Tuvalu in 2006?
Offer a terse response. -38.06. What is the difference between the Area (in %) in Togo in 2004 and the Area (in %) in Tuvalu in 2006?
Make the answer very short. 6.86. What is the difference between the Area (in %) of East Asia (developing only) in 2004 and the Area (in %) of Cabo Verde in 2007?
Ensure brevity in your answer.  28.55. What is the difference between the Area (in %) in East Asia (developing only) in 2004 and the Area (in %) in Togo in 2007?
Offer a very short reply. -16.85. What is the difference between the Area (in %) of East Asia (developing only) in 2004 and the Area (in %) of Tuvalu in 2007?
Your answer should be very brief. -12.59. What is the difference between the Area (in %) of Cabo Verde in 2004 and the Area (in %) of Togo in 2007?
Give a very brief answer. -45.65. What is the difference between the Area (in %) in Cabo Verde in 2004 and the Area (in %) in Tuvalu in 2007?
Keep it short and to the point. -41.39. What is the difference between the Area (in %) in Togo in 2004 and the Area (in %) in Tuvalu in 2007?
Keep it short and to the point. 3.52. What is the difference between the Area (in %) in East Asia (developing only) in 2005 and the Area (in %) in Cabo Verde in 2006?
Make the answer very short. 28.54. What is the difference between the Area (in %) in East Asia (developing only) in 2005 and the Area (in %) in Togo in 2006?
Make the answer very short. -12.9. What is the difference between the Area (in %) in East Asia (developing only) in 2005 and the Area (in %) in Tuvalu in 2006?
Offer a very short reply. -9.26. What is the difference between the Area (in %) of Cabo Verde in 2005 and the Area (in %) of Togo in 2006?
Your answer should be very brief. -41.69. What is the difference between the Area (in %) of Cabo Verde in 2005 and the Area (in %) of Tuvalu in 2006?
Your answer should be very brief. -38.06. What is the difference between the Area (in %) in Togo in 2005 and the Area (in %) in Tuvalu in 2006?
Offer a very short reply. 3.09. What is the difference between the Area (in %) of East Asia (developing only) in 2005 and the Area (in %) of Cabo Verde in 2007?
Offer a very short reply. 28.54. What is the difference between the Area (in %) of East Asia (developing only) in 2005 and the Area (in %) of Togo in 2007?
Your answer should be very brief. -16.86. What is the difference between the Area (in %) of East Asia (developing only) in 2005 and the Area (in %) of Tuvalu in 2007?
Your response must be concise. -12.6. What is the difference between the Area (in %) in Cabo Verde in 2005 and the Area (in %) in Togo in 2007?
Offer a terse response. -45.65. What is the difference between the Area (in %) of Cabo Verde in 2005 and the Area (in %) of Tuvalu in 2007?
Provide a succinct answer. -41.39. What is the difference between the Area (in %) of Togo in 2005 and the Area (in %) of Tuvalu in 2007?
Keep it short and to the point. -0.25. What is the difference between the Area (in %) of East Asia (developing only) in 2006 and the Area (in %) of Cabo Verde in 2007?
Keep it short and to the point. 28.41. What is the difference between the Area (in %) of East Asia (developing only) in 2006 and the Area (in %) of Togo in 2007?
Your answer should be very brief. -16.99. What is the difference between the Area (in %) of East Asia (developing only) in 2006 and the Area (in %) of Tuvalu in 2007?
Your response must be concise. -12.73. What is the difference between the Area (in %) in Cabo Verde in 2006 and the Area (in %) in Togo in 2007?
Your response must be concise. -45.4. What is the difference between the Area (in %) of Cabo Verde in 2006 and the Area (in %) of Tuvalu in 2007?
Your answer should be very brief. -41.14. What is the difference between the Area (in %) of Togo in 2006 and the Area (in %) of Tuvalu in 2007?
Give a very brief answer. 0.31. What is the average Area (in %) of East Asia (developing only) per year?
Provide a succinct answer. 47.67. What is the average Area (in %) of Cabo Verde per year?
Make the answer very short. 18.42. What is the average Area (in %) of Togo per year?
Give a very brief answer. 63.37. What is the average Area (in %) of Tuvalu per year?
Offer a very short reply. 58.33. In the year 2000, what is the difference between the Area (in %) in East Asia (developing only) and Area (in %) in Cabo Verde?
Provide a succinct answer. 30.68. In the year 2000, what is the difference between the Area (in %) of East Asia (developing only) and Area (in %) of Togo?
Your answer should be compact. -18.45. In the year 2000, what is the difference between the Area (in %) of East Asia (developing only) and Area (in %) of Tuvalu?
Your answer should be compact. -18.37. In the year 2000, what is the difference between the Area (in %) of Cabo Verde and Area (in %) of Togo?
Your response must be concise. -49.12. In the year 2000, what is the difference between the Area (in %) of Cabo Verde and Area (in %) of Tuvalu?
Provide a succinct answer. -49.05. In the year 2000, what is the difference between the Area (in %) in Togo and Area (in %) in Tuvalu?
Your response must be concise. 0.07. In the year 2001, what is the difference between the Area (in %) of East Asia (developing only) and Area (in %) of Cabo Verde?
Offer a very short reply. 30.09. In the year 2001, what is the difference between the Area (in %) in East Asia (developing only) and Area (in %) in Togo?
Ensure brevity in your answer.  -15.78. In the year 2001, what is the difference between the Area (in %) of East Asia (developing only) and Area (in %) of Tuvalu?
Ensure brevity in your answer.  -8.46. In the year 2001, what is the difference between the Area (in %) of Cabo Verde and Area (in %) of Togo?
Keep it short and to the point. -45.87. In the year 2001, what is the difference between the Area (in %) in Cabo Verde and Area (in %) in Tuvalu?
Provide a short and direct response. -38.55. In the year 2001, what is the difference between the Area (in %) in Togo and Area (in %) in Tuvalu?
Provide a succinct answer. 7.32. In the year 2002, what is the difference between the Area (in %) in East Asia (developing only) and Area (in %) in Cabo Verde?
Ensure brevity in your answer.  29.78. In the year 2002, what is the difference between the Area (in %) in East Asia (developing only) and Area (in %) in Togo?
Ensure brevity in your answer.  -16.3. In the year 2002, what is the difference between the Area (in %) in East Asia (developing only) and Area (in %) in Tuvalu?
Make the answer very short. -8.52. In the year 2002, what is the difference between the Area (in %) in Cabo Verde and Area (in %) in Togo?
Make the answer very short. -46.08. In the year 2002, what is the difference between the Area (in %) in Cabo Verde and Area (in %) in Tuvalu?
Your response must be concise. -38.3. In the year 2002, what is the difference between the Area (in %) of Togo and Area (in %) of Tuvalu?
Provide a succinct answer. 7.78. In the year 2003, what is the difference between the Area (in %) in East Asia (developing only) and Area (in %) in Cabo Verde?
Give a very brief answer. 28.83. In the year 2003, what is the difference between the Area (in %) of East Asia (developing only) and Area (in %) of Togo?
Offer a very short reply. -16.79. In the year 2003, what is the difference between the Area (in %) in East Asia (developing only) and Area (in %) in Tuvalu?
Provide a succinct answer. -9.47. In the year 2003, what is the difference between the Area (in %) of Cabo Verde and Area (in %) of Togo?
Make the answer very short. -45.62. In the year 2003, what is the difference between the Area (in %) in Cabo Verde and Area (in %) in Tuvalu?
Provide a short and direct response. -38.3. In the year 2003, what is the difference between the Area (in %) in Togo and Area (in %) in Tuvalu?
Provide a short and direct response. 7.32. In the year 2004, what is the difference between the Area (in %) in East Asia (developing only) and Area (in %) in Cabo Verde?
Your response must be concise. 28.8. In the year 2004, what is the difference between the Area (in %) in East Asia (developing only) and Area (in %) in Togo?
Keep it short and to the point. -16.11. In the year 2004, what is the difference between the Area (in %) in East Asia (developing only) and Area (in %) in Tuvalu?
Your answer should be very brief. -9.26. In the year 2004, what is the difference between the Area (in %) of Cabo Verde and Area (in %) of Togo?
Your answer should be very brief. -44.91. In the year 2004, what is the difference between the Area (in %) of Cabo Verde and Area (in %) of Tuvalu?
Provide a succinct answer. -38.06. In the year 2004, what is the difference between the Area (in %) in Togo and Area (in %) in Tuvalu?
Offer a terse response. 6.86. In the year 2005, what is the difference between the Area (in %) of East Asia (developing only) and Area (in %) of Cabo Verde?
Provide a short and direct response. 28.79. In the year 2005, what is the difference between the Area (in %) in East Asia (developing only) and Area (in %) in Togo?
Your answer should be very brief. -12.35. In the year 2005, what is the difference between the Area (in %) of East Asia (developing only) and Area (in %) of Tuvalu?
Your answer should be very brief. -9.26. In the year 2005, what is the difference between the Area (in %) in Cabo Verde and Area (in %) in Togo?
Your response must be concise. -41.14. In the year 2005, what is the difference between the Area (in %) in Cabo Verde and Area (in %) in Tuvalu?
Your answer should be very brief. -38.06. In the year 2005, what is the difference between the Area (in %) of Togo and Area (in %) of Tuvalu?
Ensure brevity in your answer.  3.09. In the year 2006, what is the difference between the Area (in %) of East Asia (developing only) and Area (in %) of Cabo Verde?
Make the answer very short. 28.41. In the year 2006, what is the difference between the Area (in %) in East Asia (developing only) and Area (in %) in Togo?
Provide a short and direct response. -13.03. In the year 2006, what is the difference between the Area (in %) in East Asia (developing only) and Area (in %) in Tuvalu?
Your answer should be very brief. -9.39. In the year 2006, what is the difference between the Area (in %) in Cabo Verde and Area (in %) in Togo?
Provide a succinct answer. -41.45. In the year 2006, what is the difference between the Area (in %) in Cabo Verde and Area (in %) in Tuvalu?
Keep it short and to the point. -37.81. In the year 2006, what is the difference between the Area (in %) of Togo and Area (in %) of Tuvalu?
Your answer should be compact. 3.64. In the year 2007, what is the difference between the Area (in %) in East Asia (developing only) and Area (in %) in Cabo Verde?
Keep it short and to the point. 28.58. In the year 2007, what is the difference between the Area (in %) of East Asia (developing only) and Area (in %) of Togo?
Your answer should be very brief. -16.82. In the year 2007, what is the difference between the Area (in %) of East Asia (developing only) and Area (in %) of Tuvalu?
Your answer should be compact. -12.56. In the year 2007, what is the difference between the Area (in %) in Cabo Verde and Area (in %) in Togo?
Your answer should be very brief. -45.4. In the year 2007, what is the difference between the Area (in %) in Cabo Verde and Area (in %) in Tuvalu?
Ensure brevity in your answer.  -41.14. In the year 2007, what is the difference between the Area (in %) of Togo and Area (in %) of Tuvalu?
Your answer should be very brief. 4.26. What is the ratio of the Area (in %) in East Asia (developing only) in 2000 to that in 2001?
Provide a short and direct response. 1. What is the ratio of the Area (in %) of Cabo Verde in 2000 to that in 2001?
Make the answer very short. 0.97. What is the ratio of the Area (in %) in Togo in 2000 to that in 2001?
Give a very brief answer. 1.04. What is the ratio of the Area (in %) in Tuvalu in 2000 to that in 2001?
Your answer should be very brief. 1.18. What is the ratio of the Area (in %) in Cabo Verde in 2000 to that in 2002?
Your answer should be compact. 0.96. What is the ratio of the Area (in %) in Togo in 2000 to that in 2002?
Provide a succinct answer. 1.04. What is the ratio of the Area (in %) in Tuvalu in 2000 to that in 2002?
Provide a succinct answer. 1.18. What is the ratio of the Area (in %) in East Asia (developing only) in 2000 to that in 2003?
Give a very brief answer. 1.02. What is the ratio of the Area (in %) of Cabo Verde in 2000 to that in 2003?
Provide a short and direct response. 0.96. What is the ratio of the Area (in %) in Togo in 2000 to that in 2003?
Your answer should be compact. 1.04. What is the ratio of the Area (in %) in Tuvalu in 2000 to that in 2003?
Your response must be concise. 1.18. What is the ratio of the Area (in %) in East Asia (developing only) in 2000 to that in 2004?
Give a very brief answer. 1.02. What is the ratio of the Area (in %) in Cabo Verde in 2000 to that in 2004?
Offer a very short reply. 0.95. What is the ratio of the Area (in %) of Togo in 2000 to that in 2004?
Make the answer very short. 1.05. What is the ratio of the Area (in %) in Tuvalu in 2000 to that in 2004?
Offer a very short reply. 1.18. What is the ratio of the Area (in %) in East Asia (developing only) in 2000 to that in 2005?
Make the answer very short. 1.02. What is the ratio of the Area (in %) in Cabo Verde in 2000 to that in 2005?
Offer a very short reply. 0.95. What is the ratio of the Area (in %) in Togo in 2000 to that in 2005?
Offer a very short reply. 1.12. What is the ratio of the Area (in %) of Tuvalu in 2000 to that in 2005?
Provide a short and direct response. 1.18. What is the ratio of the Area (in %) in East Asia (developing only) in 2000 to that in 2006?
Ensure brevity in your answer.  1.02. What is the ratio of the Area (in %) in Cabo Verde in 2000 to that in 2006?
Make the answer very short. 0.93. What is the ratio of the Area (in %) of Togo in 2000 to that in 2006?
Ensure brevity in your answer.  1.11. What is the ratio of the Area (in %) of Tuvalu in 2000 to that in 2006?
Offer a very short reply. 1.18. What is the ratio of the Area (in %) in East Asia (developing only) in 2000 to that in 2007?
Your answer should be compact. 1.02. What is the ratio of the Area (in %) in Cabo Verde in 2000 to that in 2007?
Ensure brevity in your answer.  0.93. What is the ratio of the Area (in %) of Togo in 2000 to that in 2007?
Provide a succinct answer. 1.04. What is the ratio of the Area (in %) in Cabo Verde in 2001 to that in 2002?
Your response must be concise. 0.99. What is the ratio of the Area (in %) of Tuvalu in 2001 to that in 2002?
Make the answer very short. 1. What is the ratio of the Area (in %) of East Asia (developing only) in 2001 to that in 2003?
Give a very brief answer. 1.02. What is the ratio of the Area (in %) of Cabo Verde in 2001 to that in 2003?
Provide a succinct answer. 0.99. What is the ratio of the Area (in %) in East Asia (developing only) in 2001 to that in 2004?
Offer a terse response. 1.02. What is the ratio of the Area (in %) in Cabo Verde in 2001 to that in 2004?
Provide a succinct answer. 0.97. What is the ratio of the Area (in %) in Togo in 2001 to that in 2004?
Make the answer very short. 1.01. What is the ratio of the Area (in %) of Cabo Verde in 2001 to that in 2005?
Your response must be concise. 0.97. What is the ratio of the Area (in %) in Togo in 2001 to that in 2005?
Give a very brief answer. 1.07. What is the ratio of the Area (in %) in East Asia (developing only) in 2001 to that in 2006?
Offer a very short reply. 1.02. What is the ratio of the Area (in %) in Cabo Verde in 2001 to that in 2006?
Offer a very short reply. 0.96. What is the ratio of the Area (in %) in Togo in 2001 to that in 2006?
Ensure brevity in your answer.  1.06. What is the ratio of the Area (in %) of Tuvalu in 2001 to that in 2006?
Your response must be concise. 1. What is the ratio of the Area (in %) of East Asia (developing only) in 2001 to that in 2007?
Your response must be concise. 1.02. What is the ratio of the Area (in %) of Cabo Verde in 2001 to that in 2007?
Ensure brevity in your answer.  0.96. What is the ratio of the Area (in %) in Togo in 2001 to that in 2007?
Offer a very short reply. 1. What is the ratio of the Area (in %) of East Asia (developing only) in 2002 to that in 2003?
Your answer should be very brief. 1.02. What is the ratio of the Area (in %) in East Asia (developing only) in 2002 to that in 2004?
Offer a very short reply. 1.02. What is the ratio of the Area (in %) of Cabo Verde in 2002 to that in 2004?
Your answer should be compact. 0.99. What is the ratio of the Area (in %) of Togo in 2002 to that in 2004?
Ensure brevity in your answer.  1.01. What is the ratio of the Area (in %) of East Asia (developing only) in 2002 to that in 2005?
Give a very brief answer. 1.02. What is the ratio of the Area (in %) in Cabo Verde in 2002 to that in 2005?
Offer a very short reply. 0.99. What is the ratio of the Area (in %) of Togo in 2002 to that in 2005?
Offer a very short reply. 1.08. What is the ratio of the Area (in %) of Tuvalu in 2002 to that in 2005?
Your answer should be compact. 1. What is the ratio of the Area (in %) of East Asia (developing only) in 2002 to that in 2006?
Provide a short and direct response. 1.02. What is the ratio of the Area (in %) of Cabo Verde in 2002 to that in 2006?
Offer a terse response. 0.97. What is the ratio of the Area (in %) in Togo in 2002 to that in 2006?
Make the answer very short. 1.07. What is the ratio of the Area (in %) in East Asia (developing only) in 2002 to that in 2007?
Your answer should be compact. 1.01. What is the ratio of the Area (in %) in Cabo Verde in 2002 to that in 2007?
Offer a very short reply. 0.97. What is the ratio of the Area (in %) in Togo in 2002 to that in 2007?
Ensure brevity in your answer.  1. What is the ratio of the Area (in %) in East Asia (developing only) in 2003 to that in 2004?
Provide a succinct answer. 1. What is the ratio of the Area (in %) in Cabo Verde in 2003 to that in 2004?
Provide a succinct answer. 0.99. What is the ratio of the Area (in %) in Tuvalu in 2003 to that in 2004?
Keep it short and to the point. 1. What is the ratio of the Area (in %) in East Asia (developing only) in 2003 to that in 2005?
Offer a very short reply. 1. What is the ratio of the Area (in %) of Cabo Verde in 2003 to that in 2005?
Your answer should be very brief. 0.99. What is the ratio of the Area (in %) of Togo in 2003 to that in 2005?
Give a very brief answer. 1.07. What is the ratio of the Area (in %) of Cabo Verde in 2003 to that in 2006?
Provide a succinct answer. 0.97. What is the ratio of the Area (in %) of Togo in 2003 to that in 2006?
Your answer should be very brief. 1.06. What is the ratio of the Area (in %) in Tuvalu in 2003 to that in 2006?
Your answer should be compact. 1. What is the ratio of the Area (in %) of Cabo Verde in 2003 to that in 2007?
Provide a succinct answer. 0.97. What is the ratio of the Area (in %) in Togo in 2003 to that in 2007?
Offer a very short reply. 1. What is the ratio of the Area (in %) in East Asia (developing only) in 2004 to that in 2005?
Provide a succinct answer. 1. What is the ratio of the Area (in %) of Togo in 2004 to that in 2005?
Make the answer very short. 1.06. What is the ratio of the Area (in %) in Togo in 2004 to that in 2006?
Offer a terse response. 1.05. What is the ratio of the Area (in %) of Cabo Verde in 2004 to that in 2007?
Keep it short and to the point. 0.99. What is the ratio of the Area (in %) of Togo in 2004 to that in 2007?
Your answer should be very brief. 0.99. What is the ratio of the Area (in %) of Cabo Verde in 2005 to that in 2006?
Offer a terse response. 0.99. What is the ratio of the Area (in %) of Togo in 2005 to that in 2006?
Your response must be concise. 0.99. What is the ratio of the Area (in %) in Togo in 2005 to that in 2007?
Offer a terse response. 0.93. What is the ratio of the Area (in %) of East Asia (developing only) in 2006 to that in 2007?
Provide a succinct answer. 1. What is the ratio of the Area (in %) of Cabo Verde in 2006 to that in 2007?
Provide a succinct answer. 1. What is the ratio of the Area (in %) in Togo in 2006 to that in 2007?
Your answer should be compact. 0.94. What is the ratio of the Area (in %) of Tuvalu in 2006 to that in 2007?
Your response must be concise. 0.94. What is the difference between the highest and the second highest Area (in %) in East Asia (developing only)?
Make the answer very short. 0.09. What is the difference between the highest and the second highest Area (in %) in Togo?
Give a very brief answer. 2.3. What is the difference between the highest and the lowest Area (in %) of East Asia (developing only)?
Your response must be concise. 1.1. What is the difference between the highest and the lowest Area (in %) in Cabo Verde?
Keep it short and to the point. 1.24. What is the difference between the highest and the lowest Area (in %) in Togo?
Your response must be concise. 6.99. 